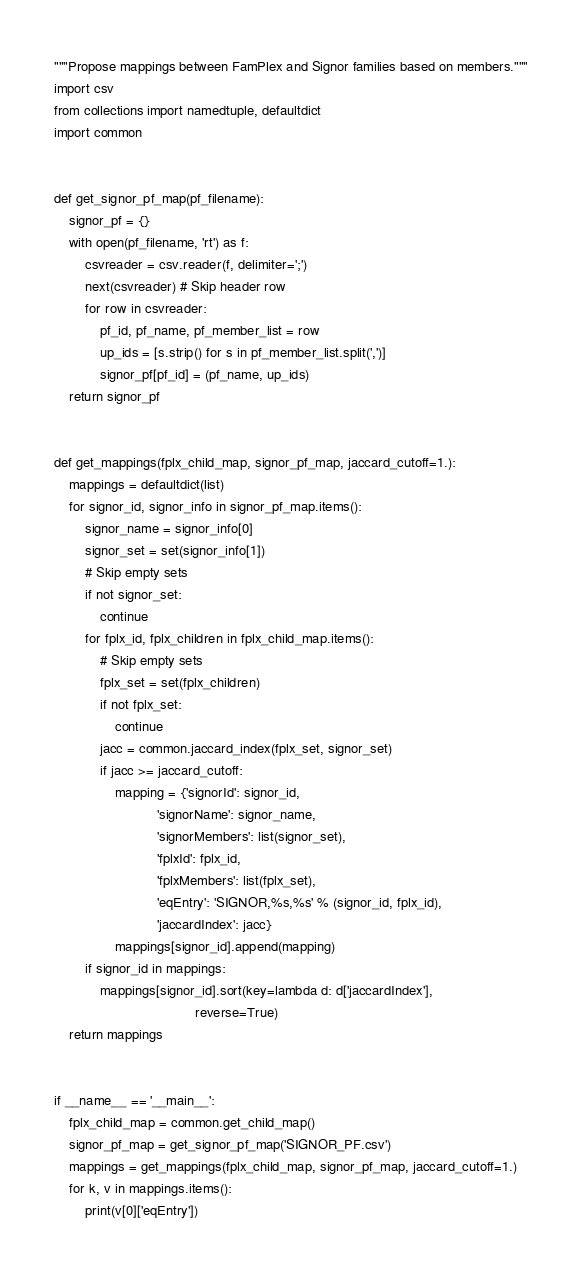Convert code to text. <code><loc_0><loc_0><loc_500><loc_500><_Python_>"""Propose mappings between FamPlex and Signor families based on members."""
import csv
from collections import namedtuple, defaultdict
import common


def get_signor_pf_map(pf_filename):
    signor_pf = {}
    with open(pf_filename, 'rt') as f:
        csvreader = csv.reader(f, delimiter=';')
        next(csvreader) # Skip header row
        for row in csvreader:
            pf_id, pf_name, pf_member_list = row
            up_ids = [s.strip() for s in pf_member_list.split(',')]
            signor_pf[pf_id] = (pf_name, up_ids)
    return signor_pf


def get_mappings(fplx_child_map, signor_pf_map, jaccard_cutoff=1.):
    mappings = defaultdict(list)
    for signor_id, signor_info in signor_pf_map.items():
        signor_name = signor_info[0]
        signor_set = set(signor_info[1])
        # Skip empty sets
        if not signor_set:
            continue
        for fplx_id, fplx_children in fplx_child_map.items():
            # Skip empty sets
            fplx_set = set(fplx_children)
            if not fplx_set:
                continue
            jacc = common.jaccard_index(fplx_set, signor_set)
            if jacc >= jaccard_cutoff:
                mapping = {'signorId': signor_id,
                           'signorName': signor_name,
                           'signorMembers': list(signor_set),
                           'fplxId': fplx_id,
                           'fplxMembers': list(fplx_set),
                           'eqEntry': 'SIGNOR,%s,%s' % (signor_id, fplx_id),
                           'jaccardIndex': jacc}
                mappings[signor_id].append(mapping)
        if signor_id in mappings:
            mappings[signor_id].sort(key=lambda d: d['jaccardIndex'],
                                     reverse=True)
    return mappings


if __name__ == '__main__':
    fplx_child_map = common.get_child_map()
    signor_pf_map = get_signor_pf_map('SIGNOR_PF.csv')
    mappings = get_mappings(fplx_child_map, signor_pf_map, jaccard_cutoff=1.)
    for k, v in mappings.items():
        print(v[0]['eqEntry'])

</code> 